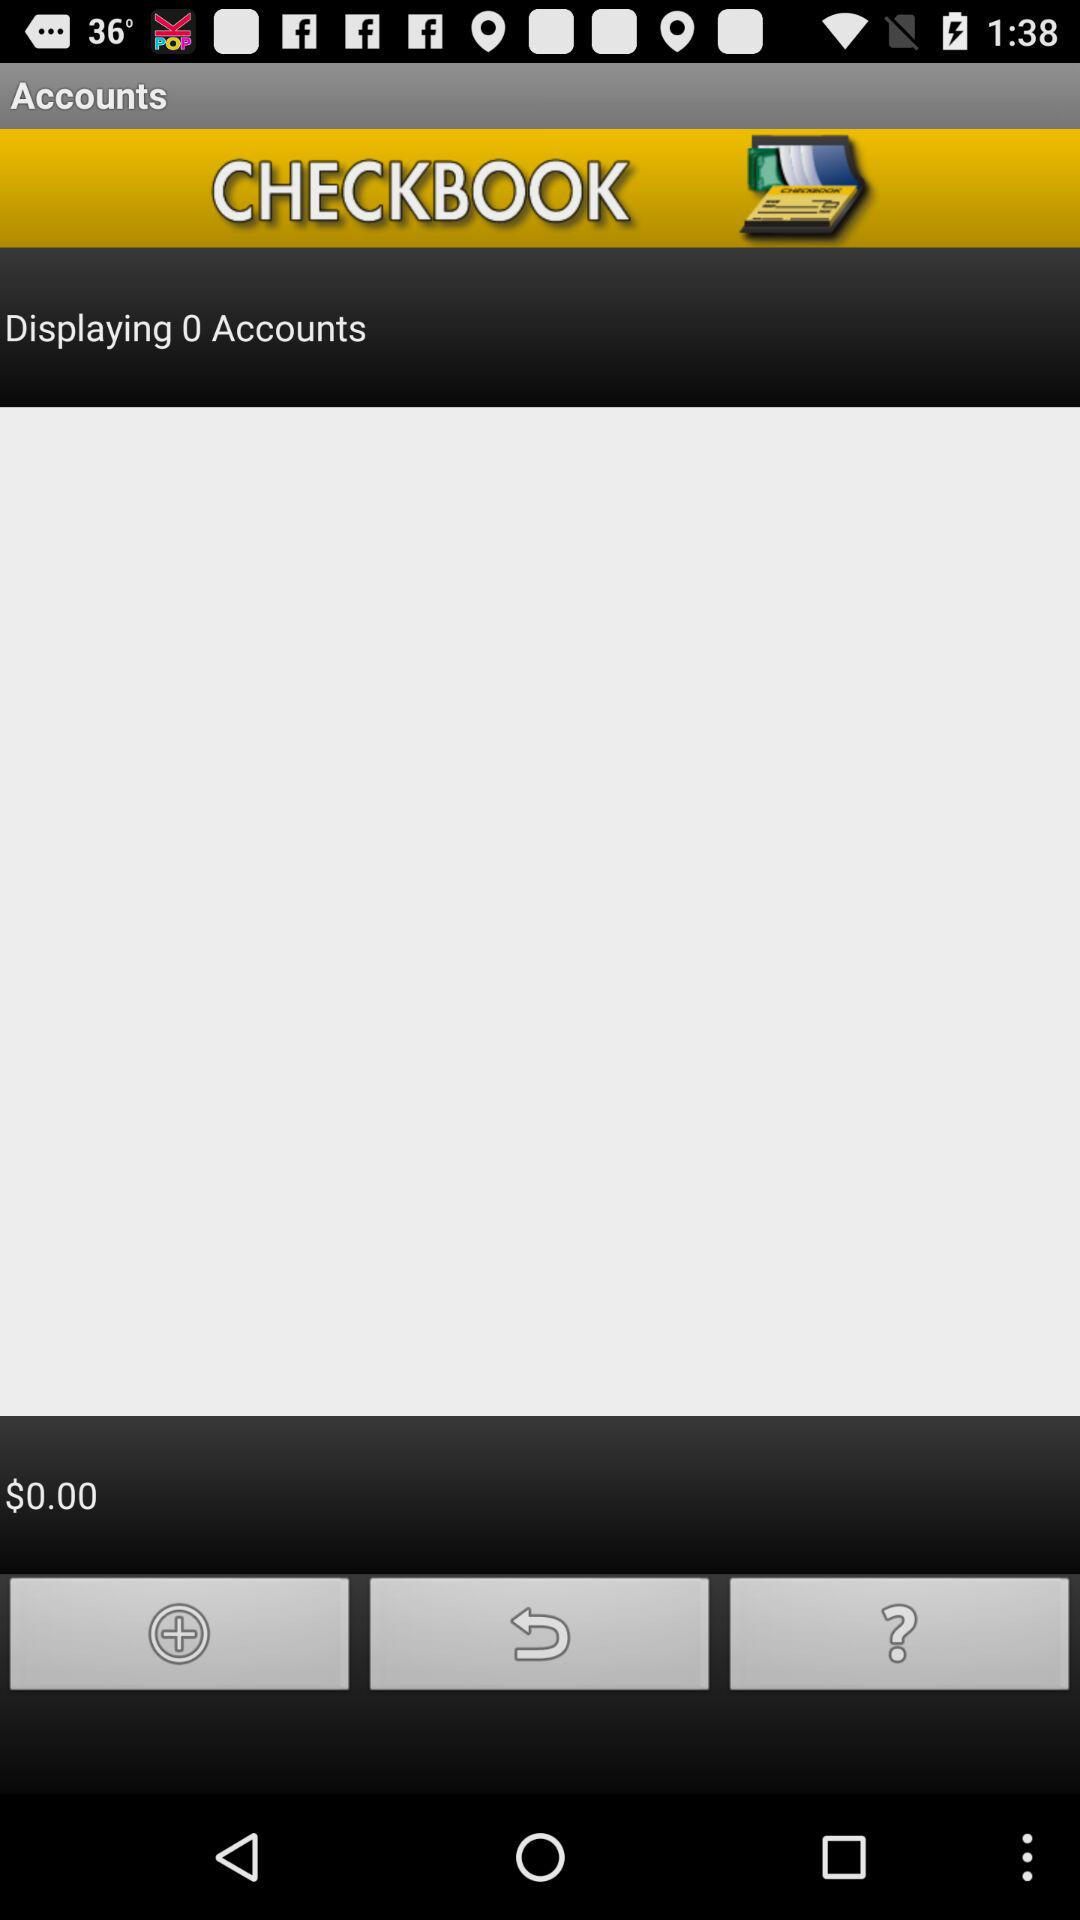How much money is in the checkbook?
Answer the question using a single word or phrase. $0.00 